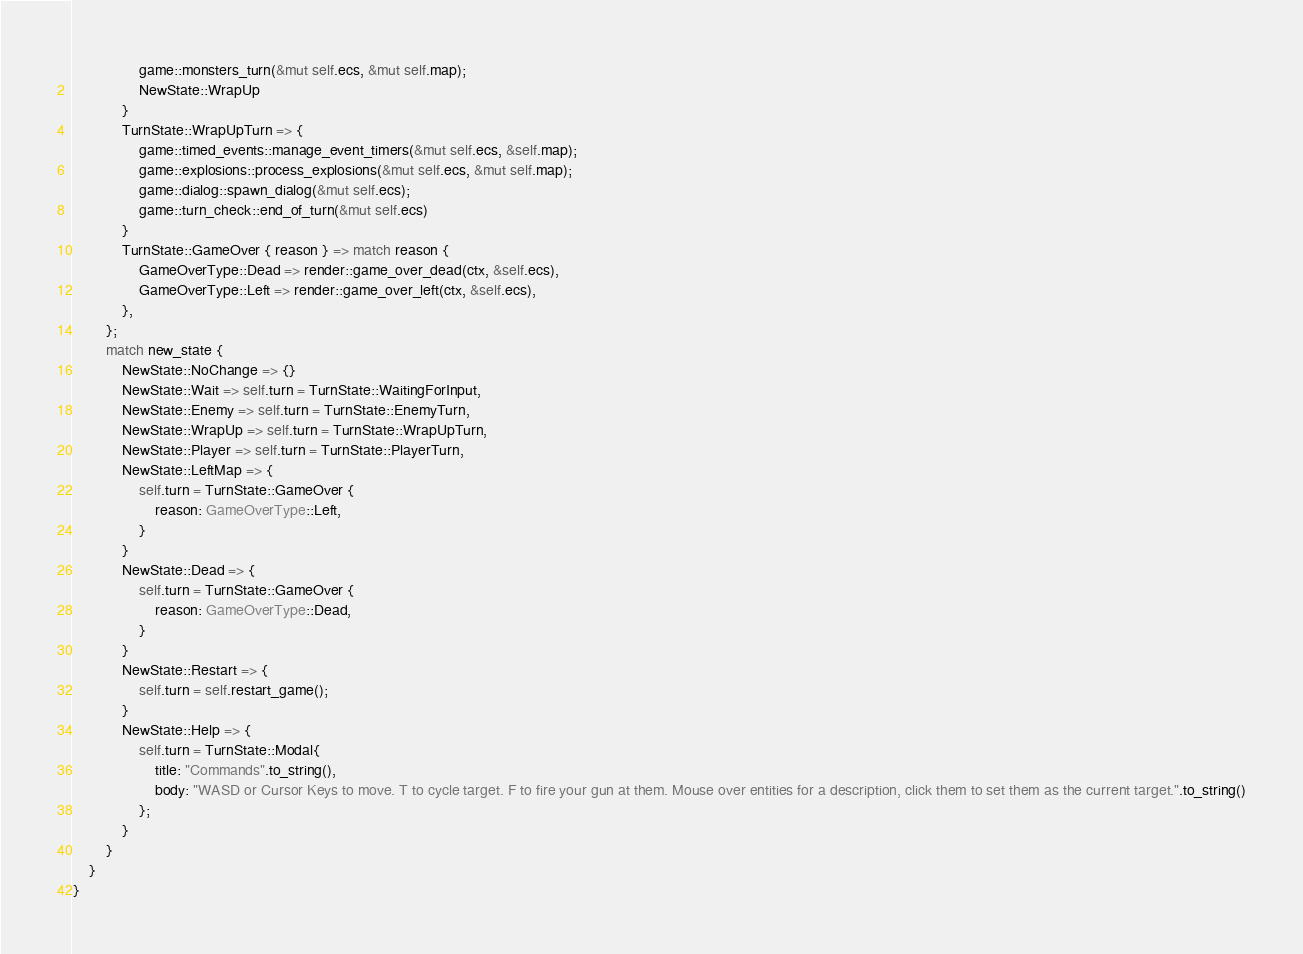Convert code to text. <code><loc_0><loc_0><loc_500><loc_500><_Rust_>                game::monsters_turn(&mut self.ecs, &mut self.map);
                NewState::WrapUp
            }
            TurnState::WrapUpTurn => {
                game::timed_events::manage_event_timers(&mut self.ecs, &self.map);
                game::explosions::process_explosions(&mut self.ecs, &mut self.map);
                game::dialog::spawn_dialog(&mut self.ecs);
                game::turn_check::end_of_turn(&mut self.ecs)
            }
            TurnState::GameOver { reason } => match reason {
                GameOverType::Dead => render::game_over_dead(ctx, &self.ecs),
                GameOverType::Left => render::game_over_left(ctx, &self.ecs),
            },
        };
        match new_state {
            NewState::NoChange => {}
            NewState::Wait => self.turn = TurnState::WaitingForInput,
            NewState::Enemy => self.turn = TurnState::EnemyTurn,
            NewState::WrapUp => self.turn = TurnState::WrapUpTurn,
            NewState::Player => self.turn = TurnState::PlayerTurn,
            NewState::LeftMap => {
                self.turn = TurnState::GameOver {
                    reason: GameOverType::Left,
                }
            }
            NewState::Dead => {
                self.turn = TurnState::GameOver {
                    reason: GameOverType::Dead,
                }
            }
            NewState::Restart => {
                self.turn = self.restart_game();
            }
            NewState::Help => {
                self.turn = TurnState::Modal{
                    title: "Commands".to_string(),
                    body: "WASD or Cursor Keys to move. T to cycle target. F to fire your gun at them. Mouse over entities for a description, click them to set them as the current target.".to_string()
                };
            }
        }
    }
}
</code> 